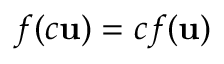Convert formula to latex. <formula><loc_0><loc_0><loc_500><loc_500>f ( c u ) = c f ( u )</formula> 